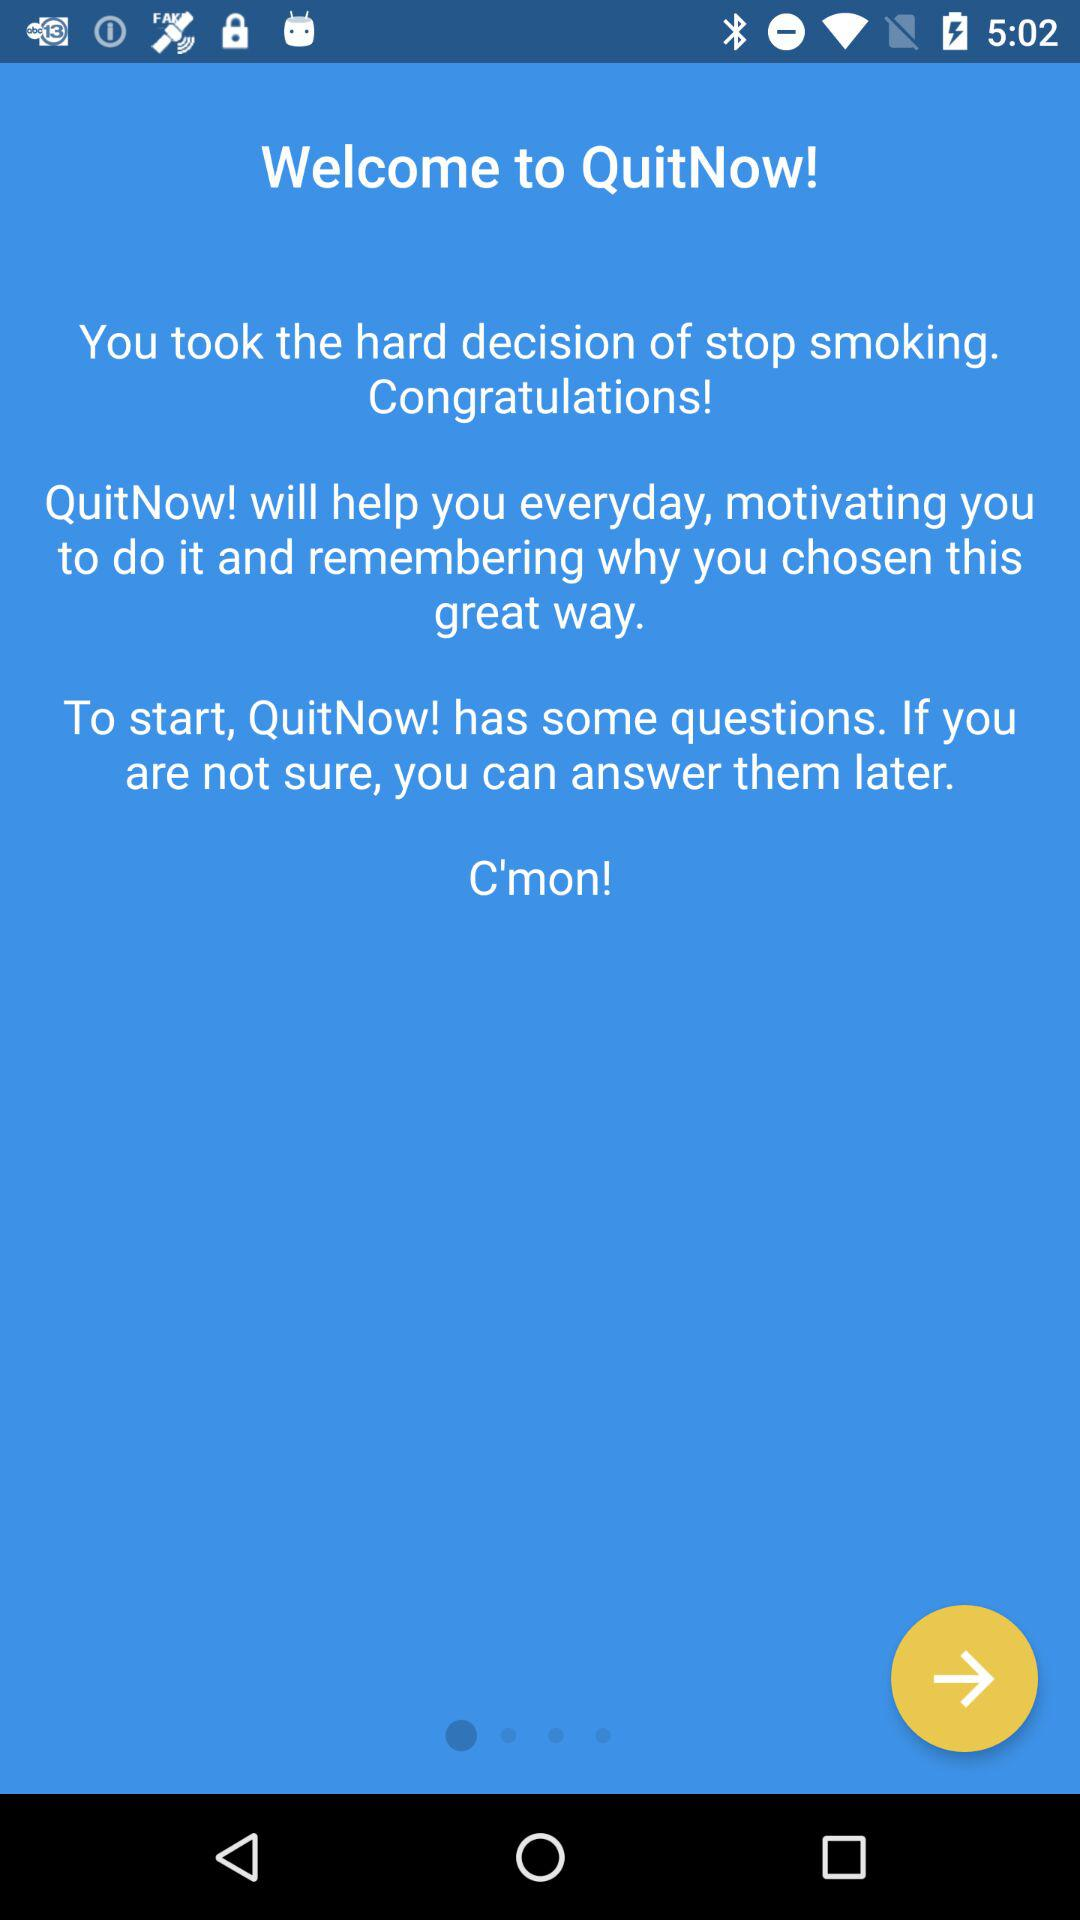When did the user start using "QuitNow!"?
When the provided information is insufficient, respond with <no answer>. <no answer> 